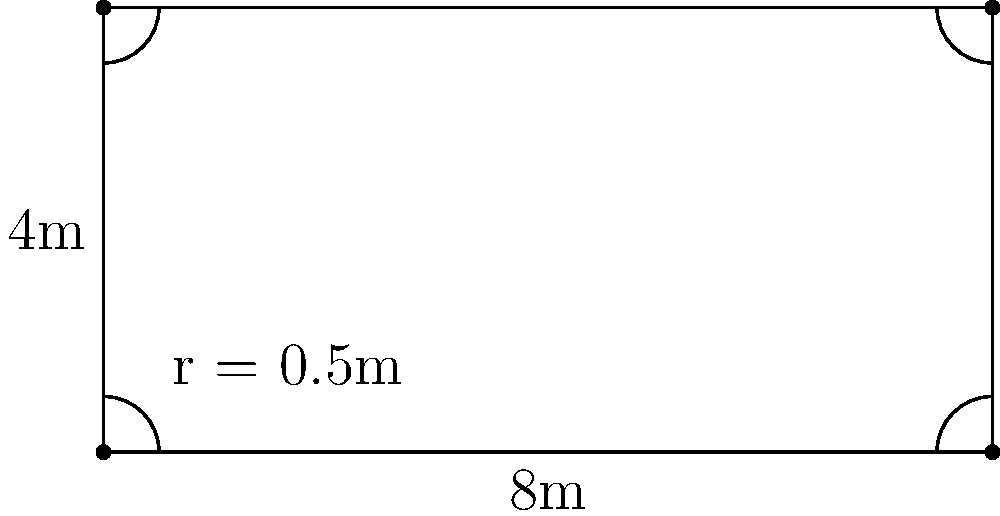As a junior risk analyst, you're tasked with calculating the perimeter of a rectangular safety barrier with rounded corners for a construction site. The barrier measures 8m in length and 4m in width, with a corner radius of 0.5m. What is the total perimeter of the safety barrier? Let's approach this step-by-step:

1) First, calculate the perimeter of the rectangle without considering the rounded corners:
   $P_{rectangle} = 2(l + w) = 2(8 + 4) = 24$ m

2) Now, we need to account for the rounded corners. Each corner reduces the perimeter by the difference between the corner of a square and a quarter circle:
   Reduction per corner = $2r - \frac{\pi r}{2}$, where $r$ is the radius

3) Calculate the reduction for one corner:
   $2(0.5) - \frac{\pi(0.5)}{2} = 1 - \frac{\pi}{4} \approx 0.2146$ m

4) There are four corners, so multiply the reduction by 4:
   Total reduction = $4(1 - \frac{\pi}{4}) \approx 0.8584$ m

5) Subtract this reduction from the rectangular perimeter:
   $P_{total} = 24 - 0.8584 = 23.1416$ m

Therefore, the total perimeter of the safety barrier is approximately 23.14 m (rounded to two decimal places).
Answer: $23.14$ m 